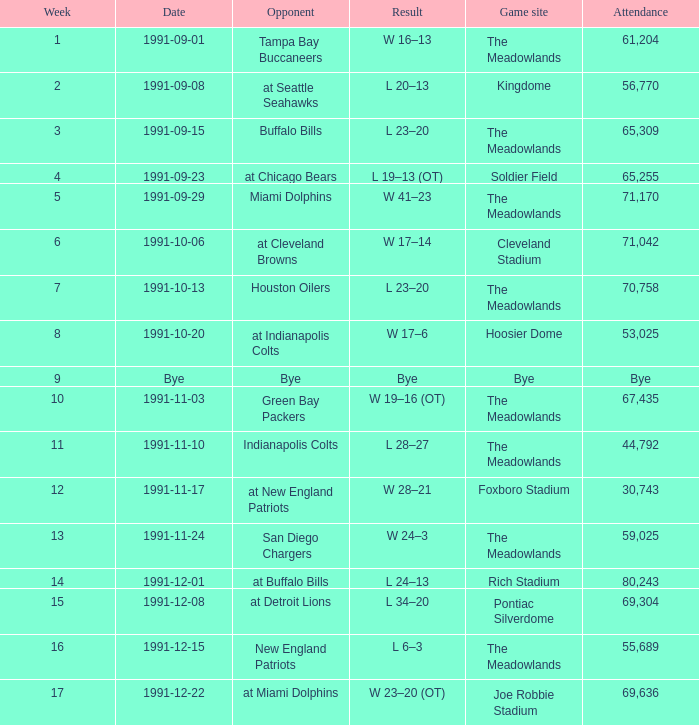Give me the full table as a dictionary. {'header': ['Week', 'Date', 'Opponent', 'Result', 'Game site', 'Attendance'], 'rows': [['1', '1991-09-01', 'Tampa Bay Buccaneers', 'W 16–13', 'The Meadowlands', '61,204'], ['2', '1991-09-08', 'at Seattle Seahawks', 'L 20–13', 'Kingdome', '56,770'], ['3', '1991-09-15', 'Buffalo Bills', 'L 23–20', 'The Meadowlands', '65,309'], ['4', '1991-09-23', 'at Chicago Bears', 'L 19–13 (OT)', 'Soldier Field', '65,255'], ['5', '1991-09-29', 'Miami Dolphins', 'W 41–23', 'The Meadowlands', '71,170'], ['6', '1991-10-06', 'at Cleveland Browns', 'W 17–14', 'Cleveland Stadium', '71,042'], ['7', '1991-10-13', 'Houston Oilers', 'L 23–20', 'The Meadowlands', '70,758'], ['8', '1991-10-20', 'at Indianapolis Colts', 'W 17–6', 'Hoosier Dome', '53,025'], ['9', 'Bye', 'Bye', 'Bye', 'Bye', 'Bye'], ['10', '1991-11-03', 'Green Bay Packers', 'W 19–16 (OT)', 'The Meadowlands', '67,435'], ['11', '1991-11-10', 'Indianapolis Colts', 'L 28–27', 'The Meadowlands', '44,792'], ['12', '1991-11-17', 'at New England Patriots', 'W 28–21', 'Foxboro Stadium', '30,743'], ['13', '1991-11-24', 'San Diego Chargers', 'W 24–3', 'The Meadowlands', '59,025'], ['14', '1991-12-01', 'at Buffalo Bills', 'L 24–13', 'Rich Stadium', '80,243'], ['15', '1991-12-08', 'at Detroit Lions', 'L 34–20', 'Pontiac Silverdome', '69,304'], ['16', '1991-12-15', 'New England Patriots', 'L 6–3', 'The Meadowlands', '55,689'], ['17', '1991-12-22', 'at Miami Dolphins', 'W 23–20 (OT)', 'Joe Robbie Stadium', '69,636']]} What was the Attendance in Week 17? 69636.0. 